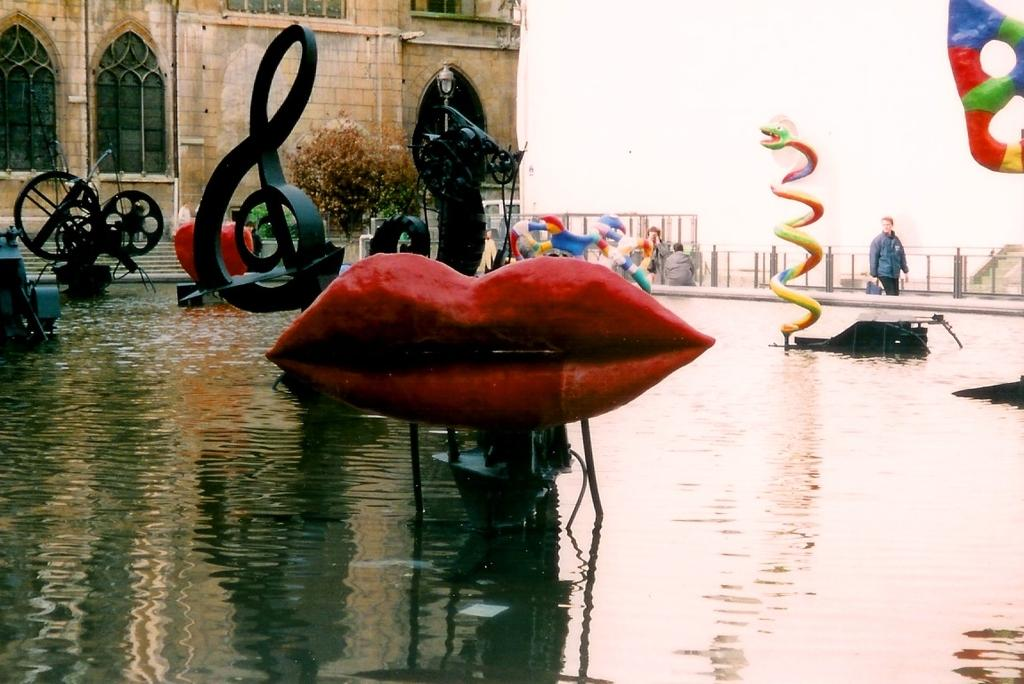What is the main element in the picture? There is water in the picture. What can be seen within the water? There are symbols present in the water. What type of natural element is visible in the picture? There is a tree in the picture. What type of man-made structure is visible in the picture? There is a building in the picture. Who or what is present in the picture? There are people present in the picture. What is the condition of the sky in the picture? The sky is clear in the picture. How much salt is dissolved in the water in the image? There is no information about the salt content in the water in the image. What type of street can be seen in the image? There is no street present in the image. 